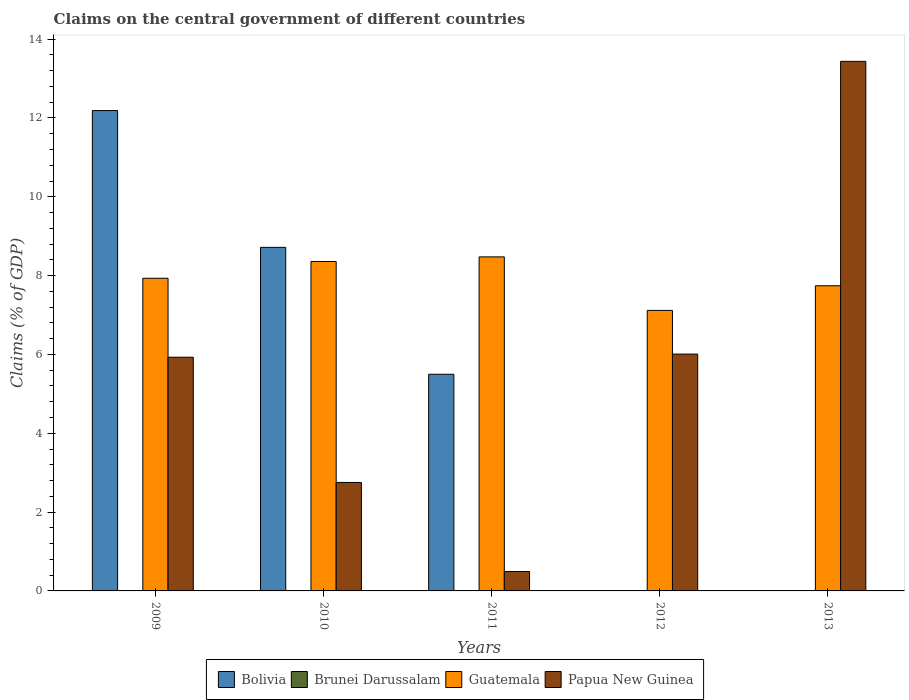How many groups of bars are there?
Make the answer very short. 5. Are the number of bars per tick equal to the number of legend labels?
Offer a very short reply. No. Are the number of bars on each tick of the X-axis equal?
Provide a succinct answer. No. How many bars are there on the 3rd tick from the right?
Your answer should be compact. 3. What is the label of the 4th group of bars from the left?
Your response must be concise. 2012. In how many cases, is the number of bars for a given year not equal to the number of legend labels?
Your answer should be compact. 5. What is the percentage of GDP claimed on the central government in Bolivia in 2011?
Offer a terse response. 5.5. Across all years, what is the maximum percentage of GDP claimed on the central government in Papua New Guinea?
Ensure brevity in your answer.  13.44. What is the total percentage of GDP claimed on the central government in Guatemala in the graph?
Offer a very short reply. 39.62. What is the difference between the percentage of GDP claimed on the central government in Guatemala in 2009 and that in 2012?
Make the answer very short. 0.82. What is the difference between the percentage of GDP claimed on the central government in Brunei Darussalam in 2011 and the percentage of GDP claimed on the central government in Bolivia in 2010?
Your response must be concise. -8.72. What is the average percentage of GDP claimed on the central government in Bolivia per year?
Provide a succinct answer. 5.28. In the year 2010, what is the difference between the percentage of GDP claimed on the central government in Guatemala and percentage of GDP claimed on the central government in Papua New Guinea?
Your answer should be very brief. 5.61. In how many years, is the percentage of GDP claimed on the central government in Bolivia greater than 13.6 %?
Your answer should be compact. 0. What is the ratio of the percentage of GDP claimed on the central government in Guatemala in 2010 to that in 2011?
Ensure brevity in your answer.  0.99. Is the difference between the percentage of GDP claimed on the central government in Guatemala in 2009 and 2010 greater than the difference between the percentage of GDP claimed on the central government in Papua New Guinea in 2009 and 2010?
Your answer should be very brief. No. What is the difference between the highest and the second highest percentage of GDP claimed on the central government in Guatemala?
Ensure brevity in your answer.  0.12. What is the difference between the highest and the lowest percentage of GDP claimed on the central government in Papua New Guinea?
Make the answer very short. 12.94. In how many years, is the percentage of GDP claimed on the central government in Papua New Guinea greater than the average percentage of GDP claimed on the central government in Papua New Guinea taken over all years?
Make the answer very short. 3. How many bars are there?
Your response must be concise. 13. Are all the bars in the graph horizontal?
Keep it short and to the point. No. How many years are there in the graph?
Offer a very short reply. 5. Are the values on the major ticks of Y-axis written in scientific E-notation?
Your answer should be very brief. No. Does the graph contain any zero values?
Ensure brevity in your answer.  Yes. Where does the legend appear in the graph?
Make the answer very short. Bottom center. How are the legend labels stacked?
Provide a short and direct response. Horizontal. What is the title of the graph?
Your answer should be very brief. Claims on the central government of different countries. Does "Virgin Islands" appear as one of the legend labels in the graph?
Your response must be concise. No. What is the label or title of the Y-axis?
Provide a succinct answer. Claims (% of GDP). What is the Claims (% of GDP) in Bolivia in 2009?
Ensure brevity in your answer.  12.19. What is the Claims (% of GDP) in Guatemala in 2009?
Offer a terse response. 7.93. What is the Claims (% of GDP) of Papua New Guinea in 2009?
Offer a very short reply. 5.93. What is the Claims (% of GDP) of Bolivia in 2010?
Provide a short and direct response. 8.72. What is the Claims (% of GDP) of Guatemala in 2010?
Your answer should be very brief. 8.36. What is the Claims (% of GDP) of Papua New Guinea in 2010?
Your response must be concise. 2.75. What is the Claims (% of GDP) in Bolivia in 2011?
Give a very brief answer. 5.5. What is the Claims (% of GDP) in Brunei Darussalam in 2011?
Provide a short and direct response. 0. What is the Claims (% of GDP) in Guatemala in 2011?
Ensure brevity in your answer.  8.47. What is the Claims (% of GDP) in Papua New Guinea in 2011?
Give a very brief answer. 0.49. What is the Claims (% of GDP) of Brunei Darussalam in 2012?
Offer a terse response. 0. What is the Claims (% of GDP) in Guatemala in 2012?
Provide a short and direct response. 7.12. What is the Claims (% of GDP) of Papua New Guinea in 2012?
Offer a terse response. 6.01. What is the Claims (% of GDP) in Bolivia in 2013?
Your response must be concise. 0. What is the Claims (% of GDP) in Guatemala in 2013?
Give a very brief answer. 7.74. What is the Claims (% of GDP) in Papua New Guinea in 2013?
Offer a terse response. 13.44. Across all years, what is the maximum Claims (% of GDP) of Bolivia?
Give a very brief answer. 12.19. Across all years, what is the maximum Claims (% of GDP) in Guatemala?
Ensure brevity in your answer.  8.47. Across all years, what is the maximum Claims (% of GDP) of Papua New Guinea?
Provide a succinct answer. 13.44. Across all years, what is the minimum Claims (% of GDP) in Bolivia?
Offer a very short reply. 0. Across all years, what is the minimum Claims (% of GDP) in Guatemala?
Give a very brief answer. 7.12. Across all years, what is the minimum Claims (% of GDP) of Papua New Guinea?
Give a very brief answer. 0.49. What is the total Claims (% of GDP) in Bolivia in the graph?
Give a very brief answer. 26.4. What is the total Claims (% of GDP) of Guatemala in the graph?
Provide a succinct answer. 39.62. What is the total Claims (% of GDP) in Papua New Guinea in the graph?
Your response must be concise. 28.62. What is the difference between the Claims (% of GDP) in Bolivia in 2009 and that in 2010?
Your answer should be very brief. 3.47. What is the difference between the Claims (% of GDP) of Guatemala in 2009 and that in 2010?
Your response must be concise. -0.43. What is the difference between the Claims (% of GDP) of Papua New Guinea in 2009 and that in 2010?
Make the answer very short. 3.18. What is the difference between the Claims (% of GDP) of Bolivia in 2009 and that in 2011?
Provide a succinct answer. 6.69. What is the difference between the Claims (% of GDP) of Guatemala in 2009 and that in 2011?
Give a very brief answer. -0.54. What is the difference between the Claims (% of GDP) of Papua New Guinea in 2009 and that in 2011?
Your answer should be very brief. 5.44. What is the difference between the Claims (% of GDP) in Guatemala in 2009 and that in 2012?
Your answer should be very brief. 0.82. What is the difference between the Claims (% of GDP) in Papua New Guinea in 2009 and that in 2012?
Provide a succinct answer. -0.08. What is the difference between the Claims (% of GDP) of Guatemala in 2009 and that in 2013?
Your response must be concise. 0.19. What is the difference between the Claims (% of GDP) in Papua New Guinea in 2009 and that in 2013?
Keep it short and to the point. -7.51. What is the difference between the Claims (% of GDP) in Bolivia in 2010 and that in 2011?
Your answer should be compact. 3.22. What is the difference between the Claims (% of GDP) in Guatemala in 2010 and that in 2011?
Your answer should be compact. -0.12. What is the difference between the Claims (% of GDP) of Papua New Guinea in 2010 and that in 2011?
Your response must be concise. 2.26. What is the difference between the Claims (% of GDP) of Guatemala in 2010 and that in 2012?
Your answer should be compact. 1.24. What is the difference between the Claims (% of GDP) of Papua New Guinea in 2010 and that in 2012?
Provide a succinct answer. -3.26. What is the difference between the Claims (% of GDP) of Guatemala in 2010 and that in 2013?
Your answer should be compact. 0.62. What is the difference between the Claims (% of GDP) in Papua New Guinea in 2010 and that in 2013?
Keep it short and to the point. -10.68. What is the difference between the Claims (% of GDP) in Guatemala in 2011 and that in 2012?
Your response must be concise. 1.36. What is the difference between the Claims (% of GDP) in Papua New Guinea in 2011 and that in 2012?
Your response must be concise. -5.52. What is the difference between the Claims (% of GDP) in Guatemala in 2011 and that in 2013?
Keep it short and to the point. 0.73. What is the difference between the Claims (% of GDP) in Papua New Guinea in 2011 and that in 2013?
Your answer should be compact. -12.94. What is the difference between the Claims (% of GDP) of Guatemala in 2012 and that in 2013?
Give a very brief answer. -0.63. What is the difference between the Claims (% of GDP) of Papua New Guinea in 2012 and that in 2013?
Provide a succinct answer. -7.43. What is the difference between the Claims (% of GDP) in Bolivia in 2009 and the Claims (% of GDP) in Guatemala in 2010?
Your answer should be compact. 3.83. What is the difference between the Claims (% of GDP) in Bolivia in 2009 and the Claims (% of GDP) in Papua New Guinea in 2010?
Your answer should be very brief. 9.44. What is the difference between the Claims (% of GDP) in Guatemala in 2009 and the Claims (% of GDP) in Papua New Guinea in 2010?
Offer a very short reply. 5.18. What is the difference between the Claims (% of GDP) of Bolivia in 2009 and the Claims (% of GDP) of Guatemala in 2011?
Ensure brevity in your answer.  3.71. What is the difference between the Claims (% of GDP) of Bolivia in 2009 and the Claims (% of GDP) of Papua New Guinea in 2011?
Your answer should be compact. 11.7. What is the difference between the Claims (% of GDP) in Guatemala in 2009 and the Claims (% of GDP) in Papua New Guinea in 2011?
Make the answer very short. 7.44. What is the difference between the Claims (% of GDP) of Bolivia in 2009 and the Claims (% of GDP) of Guatemala in 2012?
Provide a short and direct response. 5.07. What is the difference between the Claims (% of GDP) of Bolivia in 2009 and the Claims (% of GDP) of Papua New Guinea in 2012?
Your answer should be compact. 6.18. What is the difference between the Claims (% of GDP) in Guatemala in 2009 and the Claims (% of GDP) in Papua New Guinea in 2012?
Your response must be concise. 1.92. What is the difference between the Claims (% of GDP) of Bolivia in 2009 and the Claims (% of GDP) of Guatemala in 2013?
Offer a very short reply. 4.45. What is the difference between the Claims (% of GDP) of Bolivia in 2009 and the Claims (% of GDP) of Papua New Guinea in 2013?
Provide a succinct answer. -1.25. What is the difference between the Claims (% of GDP) of Guatemala in 2009 and the Claims (% of GDP) of Papua New Guinea in 2013?
Your answer should be very brief. -5.5. What is the difference between the Claims (% of GDP) of Bolivia in 2010 and the Claims (% of GDP) of Guatemala in 2011?
Your answer should be very brief. 0.24. What is the difference between the Claims (% of GDP) in Bolivia in 2010 and the Claims (% of GDP) in Papua New Guinea in 2011?
Offer a very short reply. 8.22. What is the difference between the Claims (% of GDP) in Guatemala in 2010 and the Claims (% of GDP) in Papua New Guinea in 2011?
Offer a very short reply. 7.87. What is the difference between the Claims (% of GDP) of Bolivia in 2010 and the Claims (% of GDP) of Guatemala in 2012?
Your answer should be very brief. 1.6. What is the difference between the Claims (% of GDP) of Bolivia in 2010 and the Claims (% of GDP) of Papua New Guinea in 2012?
Provide a short and direct response. 2.71. What is the difference between the Claims (% of GDP) of Guatemala in 2010 and the Claims (% of GDP) of Papua New Guinea in 2012?
Offer a terse response. 2.35. What is the difference between the Claims (% of GDP) in Bolivia in 2010 and the Claims (% of GDP) in Guatemala in 2013?
Your answer should be very brief. 0.97. What is the difference between the Claims (% of GDP) in Bolivia in 2010 and the Claims (% of GDP) in Papua New Guinea in 2013?
Give a very brief answer. -4.72. What is the difference between the Claims (% of GDP) in Guatemala in 2010 and the Claims (% of GDP) in Papua New Guinea in 2013?
Keep it short and to the point. -5.08. What is the difference between the Claims (% of GDP) in Bolivia in 2011 and the Claims (% of GDP) in Guatemala in 2012?
Ensure brevity in your answer.  -1.62. What is the difference between the Claims (% of GDP) in Bolivia in 2011 and the Claims (% of GDP) in Papua New Guinea in 2012?
Your answer should be compact. -0.51. What is the difference between the Claims (% of GDP) in Guatemala in 2011 and the Claims (% of GDP) in Papua New Guinea in 2012?
Your response must be concise. 2.47. What is the difference between the Claims (% of GDP) in Bolivia in 2011 and the Claims (% of GDP) in Guatemala in 2013?
Give a very brief answer. -2.25. What is the difference between the Claims (% of GDP) of Bolivia in 2011 and the Claims (% of GDP) of Papua New Guinea in 2013?
Provide a short and direct response. -7.94. What is the difference between the Claims (% of GDP) in Guatemala in 2011 and the Claims (% of GDP) in Papua New Guinea in 2013?
Your response must be concise. -4.96. What is the difference between the Claims (% of GDP) in Guatemala in 2012 and the Claims (% of GDP) in Papua New Guinea in 2013?
Provide a short and direct response. -6.32. What is the average Claims (% of GDP) in Bolivia per year?
Provide a succinct answer. 5.28. What is the average Claims (% of GDP) in Brunei Darussalam per year?
Your answer should be very brief. 0. What is the average Claims (% of GDP) in Guatemala per year?
Make the answer very short. 7.92. What is the average Claims (% of GDP) in Papua New Guinea per year?
Provide a short and direct response. 5.72. In the year 2009, what is the difference between the Claims (% of GDP) in Bolivia and Claims (% of GDP) in Guatemala?
Keep it short and to the point. 4.26. In the year 2009, what is the difference between the Claims (% of GDP) in Bolivia and Claims (% of GDP) in Papua New Guinea?
Offer a very short reply. 6.26. In the year 2009, what is the difference between the Claims (% of GDP) in Guatemala and Claims (% of GDP) in Papua New Guinea?
Keep it short and to the point. 2. In the year 2010, what is the difference between the Claims (% of GDP) in Bolivia and Claims (% of GDP) in Guatemala?
Give a very brief answer. 0.36. In the year 2010, what is the difference between the Claims (% of GDP) in Bolivia and Claims (% of GDP) in Papua New Guinea?
Ensure brevity in your answer.  5.97. In the year 2010, what is the difference between the Claims (% of GDP) of Guatemala and Claims (% of GDP) of Papua New Guinea?
Provide a succinct answer. 5.61. In the year 2011, what is the difference between the Claims (% of GDP) in Bolivia and Claims (% of GDP) in Guatemala?
Provide a succinct answer. -2.98. In the year 2011, what is the difference between the Claims (% of GDP) of Bolivia and Claims (% of GDP) of Papua New Guinea?
Your answer should be compact. 5. In the year 2011, what is the difference between the Claims (% of GDP) of Guatemala and Claims (% of GDP) of Papua New Guinea?
Your answer should be compact. 7.98. In the year 2012, what is the difference between the Claims (% of GDP) in Guatemala and Claims (% of GDP) in Papua New Guinea?
Offer a terse response. 1.11. In the year 2013, what is the difference between the Claims (% of GDP) of Guatemala and Claims (% of GDP) of Papua New Guinea?
Give a very brief answer. -5.69. What is the ratio of the Claims (% of GDP) of Bolivia in 2009 to that in 2010?
Your response must be concise. 1.4. What is the ratio of the Claims (% of GDP) in Guatemala in 2009 to that in 2010?
Provide a short and direct response. 0.95. What is the ratio of the Claims (% of GDP) of Papua New Guinea in 2009 to that in 2010?
Your answer should be compact. 2.15. What is the ratio of the Claims (% of GDP) of Bolivia in 2009 to that in 2011?
Provide a succinct answer. 2.22. What is the ratio of the Claims (% of GDP) of Guatemala in 2009 to that in 2011?
Ensure brevity in your answer.  0.94. What is the ratio of the Claims (% of GDP) in Papua New Guinea in 2009 to that in 2011?
Provide a short and direct response. 12.04. What is the ratio of the Claims (% of GDP) of Guatemala in 2009 to that in 2012?
Give a very brief answer. 1.11. What is the ratio of the Claims (% of GDP) in Papua New Guinea in 2009 to that in 2012?
Your answer should be compact. 0.99. What is the ratio of the Claims (% of GDP) in Guatemala in 2009 to that in 2013?
Your answer should be very brief. 1.02. What is the ratio of the Claims (% of GDP) in Papua New Guinea in 2009 to that in 2013?
Provide a short and direct response. 0.44. What is the ratio of the Claims (% of GDP) in Bolivia in 2010 to that in 2011?
Your answer should be compact. 1.59. What is the ratio of the Claims (% of GDP) of Guatemala in 2010 to that in 2011?
Your answer should be compact. 0.99. What is the ratio of the Claims (% of GDP) in Papua New Guinea in 2010 to that in 2011?
Offer a terse response. 5.59. What is the ratio of the Claims (% of GDP) of Guatemala in 2010 to that in 2012?
Offer a very short reply. 1.17. What is the ratio of the Claims (% of GDP) in Papua New Guinea in 2010 to that in 2012?
Keep it short and to the point. 0.46. What is the ratio of the Claims (% of GDP) of Guatemala in 2010 to that in 2013?
Ensure brevity in your answer.  1.08. What is the ratio of the Claims (% of GDP) in Papua New Guinea in 2010 to that in 2013?
Ensure brevity in your answer.  0.2. What is the ratio of the Claims (% of GDP) of Guatemala in 2011 to that in 2012?
Keep it short and to the point. 1.19. What is the ratio of the Claims (% of GDP) in Papua New Guinea in 2011 to that in 2012?
Ensure brevity in your answer.  0.08. What is the ratio of the Claims (% of GDP) of Guatemala in 2011 to that in 2013?
Keep it short and to the point. 1.09. What is the ratio of the Claims (% of GDP) of Papua New Guinea in 2011 to that in 2013?
Your answer should be very brief. 0.04. What is the ratio of the Claims (% of GDP) of Guatemala in 2012 to that in 2013?
Provide a succinct answer. 0.92. What is the ratio of the Claims (% of GDP) in Papua New Guinea in 2012 to that in 2013?
Make the answer very short. 0.45. What is the difference between the highest and the second highest Claims (% of GDP) in Bolivia?
Make the answer very short. 3.47. What is the difference between the highest and the second highest Claims (% of GDP) in Guatemala?
Offer a terse response. 0.12. What is the difference between the highest and the second highest Claims (% of GDP) of Papua New Guinea?
Your response must be concise. 7.43. What is the difference between the highest and the lowest Claims (% of GDP) of Bolivia?
Offer a terse response. 12.19. What is the difference between the highest and the lowest Claims (% of GDP) in Guatemala?
Offer a very short reply. 1.36. What is the difference between the highest and the lowest Claims (% of GDP) of Papua New Guinea?
Your answer should be very brief. 12.94. 